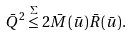Convert formula to latex. <formula><loc_0><loc_0><loc_500><loc_500>\bar { Q } ^ { 2 } \stackrel { \Sigma } { \leq } 2 \bar { M } ( \bar { u } ) \bar { R } ( \bar { u } ) .</formula> 